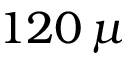<formula> <loc_0><loc_0><loc_500><loc_500>1 2 0 \, \mu</formula> 